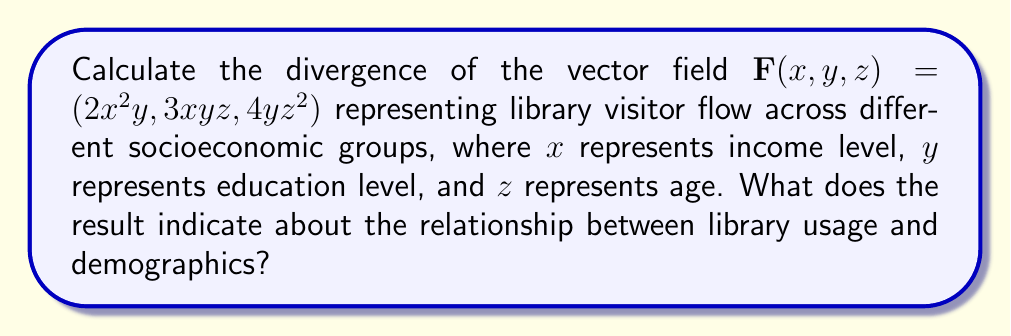Can you solve this math problem? To calculate the divergence of the vector field $\mathbf{F}(x, y, z) = (2x^2y, 3xyz, 4yz^2)$, we need to use the divergence formula in Cartesian coordinates:

$$\text{div}\mathbf{F} = \nabla \cdot \mathbf{F} = \frac{\partial F_x}{\partial x} + \frac{\partial F_y}{\partial y} + \frac{\partial F_z}{\partial z}$$

Let's calculate each partial derivative:

1. $\frac{\partial F_x}{\partial x} = \frac{\partial}{\partial x}(2x^2y) = 4xy$

2. $\frac{\partial F_y}{\partial y} = \frac{\partial}{\partial y}(3xyz) = 3xz$

3. $\frac{\partial F_z}{\partial z} = \frac{\partial}{\partial z}(4yz^2) = 8yz$

Now, we sum these partial derivatives:

$$\text{div}\mathbf{F} = 4xy + 3xz + 8yz$$

This result indicates that the divergence of the library visitor flow varies depending on the combination of income level ($x$), education level ($y$), and age ($z$). A positive divergence at a point $(x, y, z)$ suggests that there is a net outflow of library visitors from that demographic group, while a negative divergence would indicate a net inflow.

The relationship between library usage and demographics can be interpreted as follows:
1. Income and education levels have a joint effect (4xy term).
2. Income and age have a joint effect (3xz term).
3. Education level and age have the strongest joint effect (8yz term).

These interactions suggest that library usage is influenced by complex relationships between socioeconomic factors, with education level and age potentially having the most significant combined impact.
Answer: $\text{div}\mathbf{F} = 4xy + 3xz + 8yz$ 